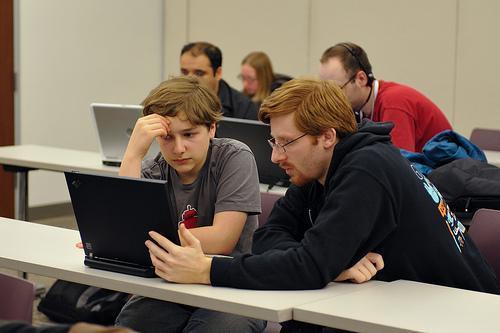How many people are there?
Give a very brief answer. 5. How many computers can be seen?
Give a very brief answer. 3. How many males are there?
Give a very brief answer. 4. 